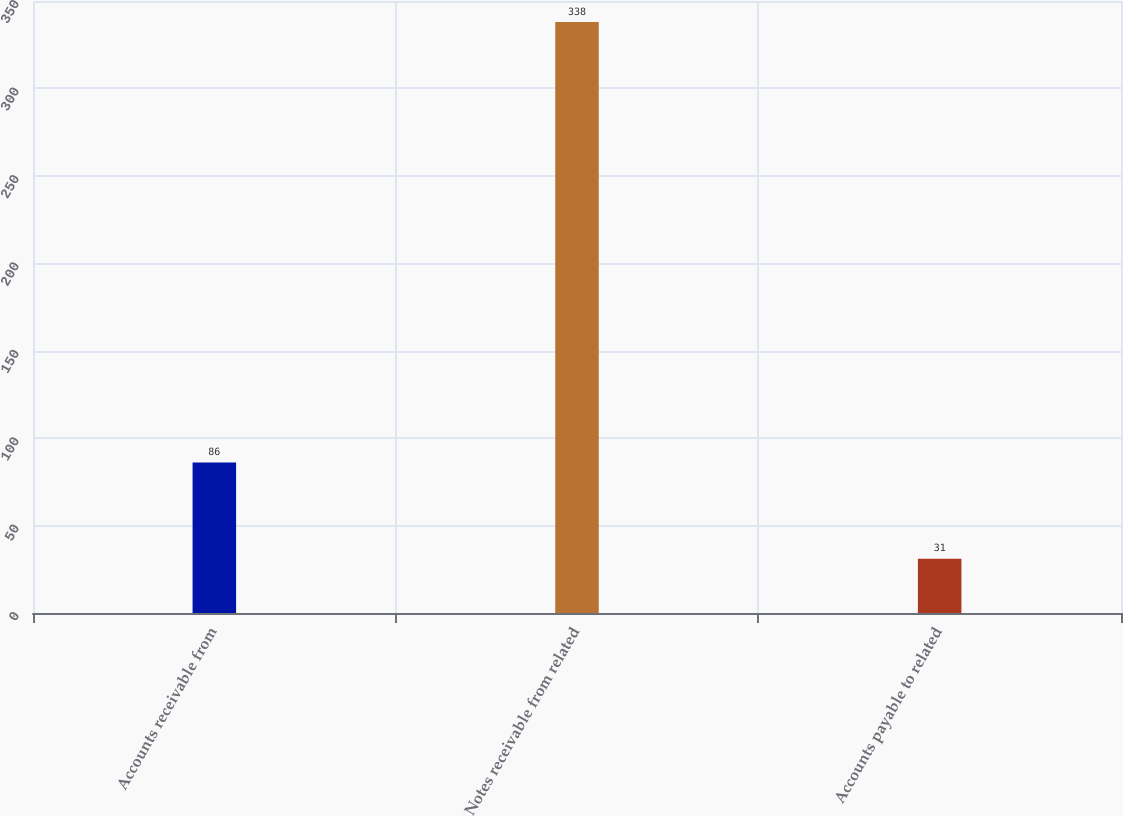<chart> <loc_0><loc_0><loc_500><loc_500><bar_chart><fcel>Accounts receivable from<fcel>Notes receivable from related<fcel>Accounts payable to related<nl><fcel>86<fcel>338<fcel>31<nl></chart> 